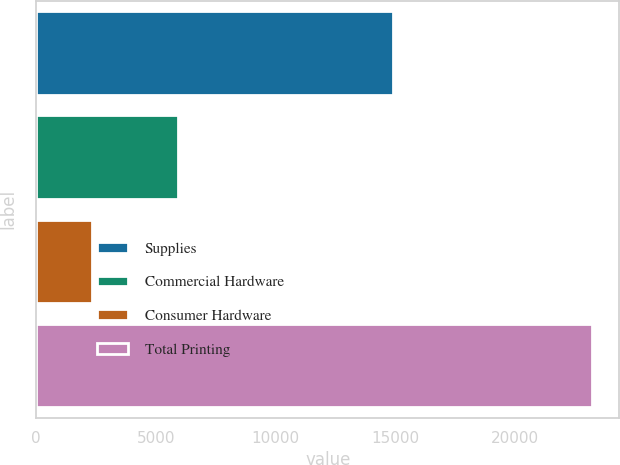<chart> <loc_0><loc_0><loc_500><loc_500><bar_chart><fcel>Supplies<fcel>Commercial Hardware<fcel>Consumer Hardware<fcel>Total Printing<nl><fcel>14917<fcel>5949<fcel>2345<fcel>23211<nl></chart> 